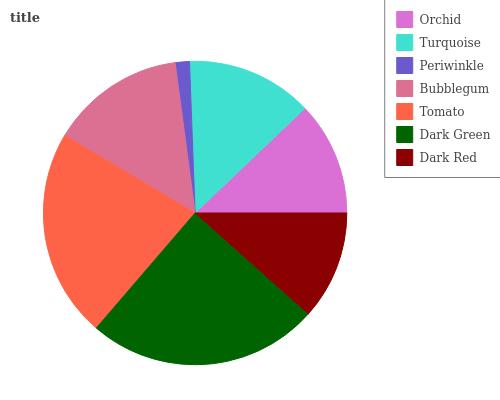Is Periwinkle the minimum?
Answer yes or no. Yes. Is Dark Green the maximum?
Answer yes or no. Yes. Is Turquoise the minimum?
Answer yes or no. No. Is Turquoise the maximum?
Answer yes or no. No. Is Turquoise greater than Orchid?
Answer yes or no. Yes. Is Orchid less than Turquoise?
Answer yes or no. Yes. Is Orchid greater than Turquoise?
Answer yes or no. No. Is Turquoise less than Orchid?
Answer yes or no. No. Is Turquoise the high median?
Answer yes or no. Yes. Is Turquoise the low median?
Answer yes or no. Yes. Is Periwinkle the high median?
Answer yes or no. No. Is Dark Red the low median?
Answer yes or no. No. 